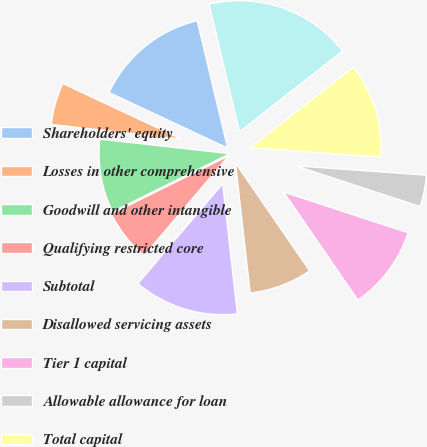<chart> <loc_0><loc_0><loc_500><loc_500><pie_chart><fcel>Shareholders' equity<fcel>Losses in other comprehensive<fcel>Goodwill and other intangible<fcel>Qualifying restricted core<fcel>Subtotal<fcel>Disallowed servicing assets<fcel>Tier 1 capital<fcel>Allowable allowance for loan<fcel>Total capital<fcel>Total average assets<nl><fcel>14.29%<fcel>5.2%<fcel>9.09%<fcel>6.49%<fcel>12.99%<fcel>7.79%<fcel>10.39%<fcel>3.9%<fcel>11.69%<fcel>18.18%<nl></chart> 